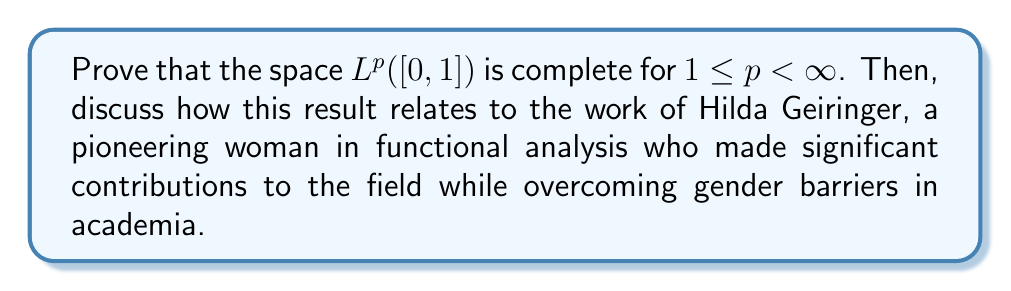Help me with this question. To prove the completeness of $L^p([0,1])$ for $1 \leq p < \infty$, we need to show that every Cauchy sequence in this space converges to an element within the space. Let's proceed step by step:

1) Let $(f_n)$ be a Cauchy sequence in $L^p([0,1])$. This means that for any $\epsilon > 0$, there exists an $N \in \mathbb{N}$ such that for all $m, n \geq N$:

   $$\|f_m - f_n\|_p < \epsilon$$

2) By the definition of the $L^p$ norm, this means:

   $$\left(\int_0^1 |f_m(x) - f_n(x)|^p dx\right)^{1/p} < \epsilon$$

3) Now, we can extract a subsequence $(f_{n_k})$ such that:

   $$\|f_{n_{k+1}} - f_{n_k}\|_p < 2^{-k}$$

4) Define a new sequence $(g_k)$ as:

   $$g_k = \sum_{i=1}^k |f_{n_{i+1}} - f_{n_i}|$$

5) The series $\sum_{k=1}^{\infty} \|f_{n_{k+1}} - f_{n_k}\|_p$ converges because:

   $$\sum_{k=1}^{\infty} \|f_{n_{k+1}} - f_{n_k}\|_p < \sum_{k=1}^{\infty} 2^{-k} = 1$$

6) By Minkowski's inequality, we have:

   $$\|g_k\|_p \leq \sum_{i=1}^k \|f_{n_{i+1}} - f_{n_i}\|_p < 1$$

7) Therefore, $(g_k)$ is a bounded increasing sequence in $L^p([0,1])$. By the Monotone Convergence Theorem, $g_k$ converges pointwise to some $g \in L^p([0,1])$.

8) Now, we can show that $(f_{n_k})$ converges pointwise to some function $f$:

   $$f = f_{n_1} + \sum_{k=1}^{\infty} (f_{n_{k+1}} - f_{n_k})$$

9) We can prove that $f \in L^p([0,1])$ and that $f_{n_k} \to f$ in $L^p$ norm.

10) Finally, since $(f_{n_k})$ was an arbitrary subsequence of our original Cauchy sequence $(f_n)$, we can conclude that $(f_n)$ itself converges to $f$ in $L^p$ norm.

This proves that $L^p([0,1])$ is complete for $1 \leq p < \infty$.

Regarding Hilda Geiringer's contributions:

Hilda Geiringer (1893-1973) was a prominent mathematician who made significant contributions to probability theory, statistics, and functional analysis. Despite facing gender discrimination and being forced to flee Nazi persecution, she persevered and made lasting impacts on the field.

Geiringer's work on functional analysis, particularly her studies on orthogonal polynomials and summation methods, relates to the completeness of $L^p$ spaces. Her research helped lay the groundwork for understanding the properties of function spaces, which is crucial in many areas of analysis.

The completeness of $L^p$ spaces is fundamental in functional analysis, and understanding this property is essential for developing more advanced concepts in the field. Geiringer's contributions, along with those of other pioneering women in mathematics, have helped shape our understanding of these spaces and their applications in various branches of mathematics and physics.

By highlighting Geiringer's work in connection with this fundamental result, we emphasize the importance of women's contributions to functional analysis and mathematics as a whole, despite the historical barriers they faced in academia.
Answer: $L^p([0,1])$ is complete for $1 \leq p < \infty$. This result is proven by showing that every Cauchy sequence in $L^p([0,1])$ converges to an element within the space. The proof involves extracting a convergent subsequence, constructing a limiting function, and demonstrating that this function belongs to $L^p([0,1])$. Hilda Geiringer's work on functional analysis, particularly in the areas of orthogonal polynomials and summation methods, relates to the properties of function spaces like $L^p$. Her contributions, despite facing gender discrimination, helped advance the field and paved the way for a deeper understanding of these fundamental spaces in functional analysis. 